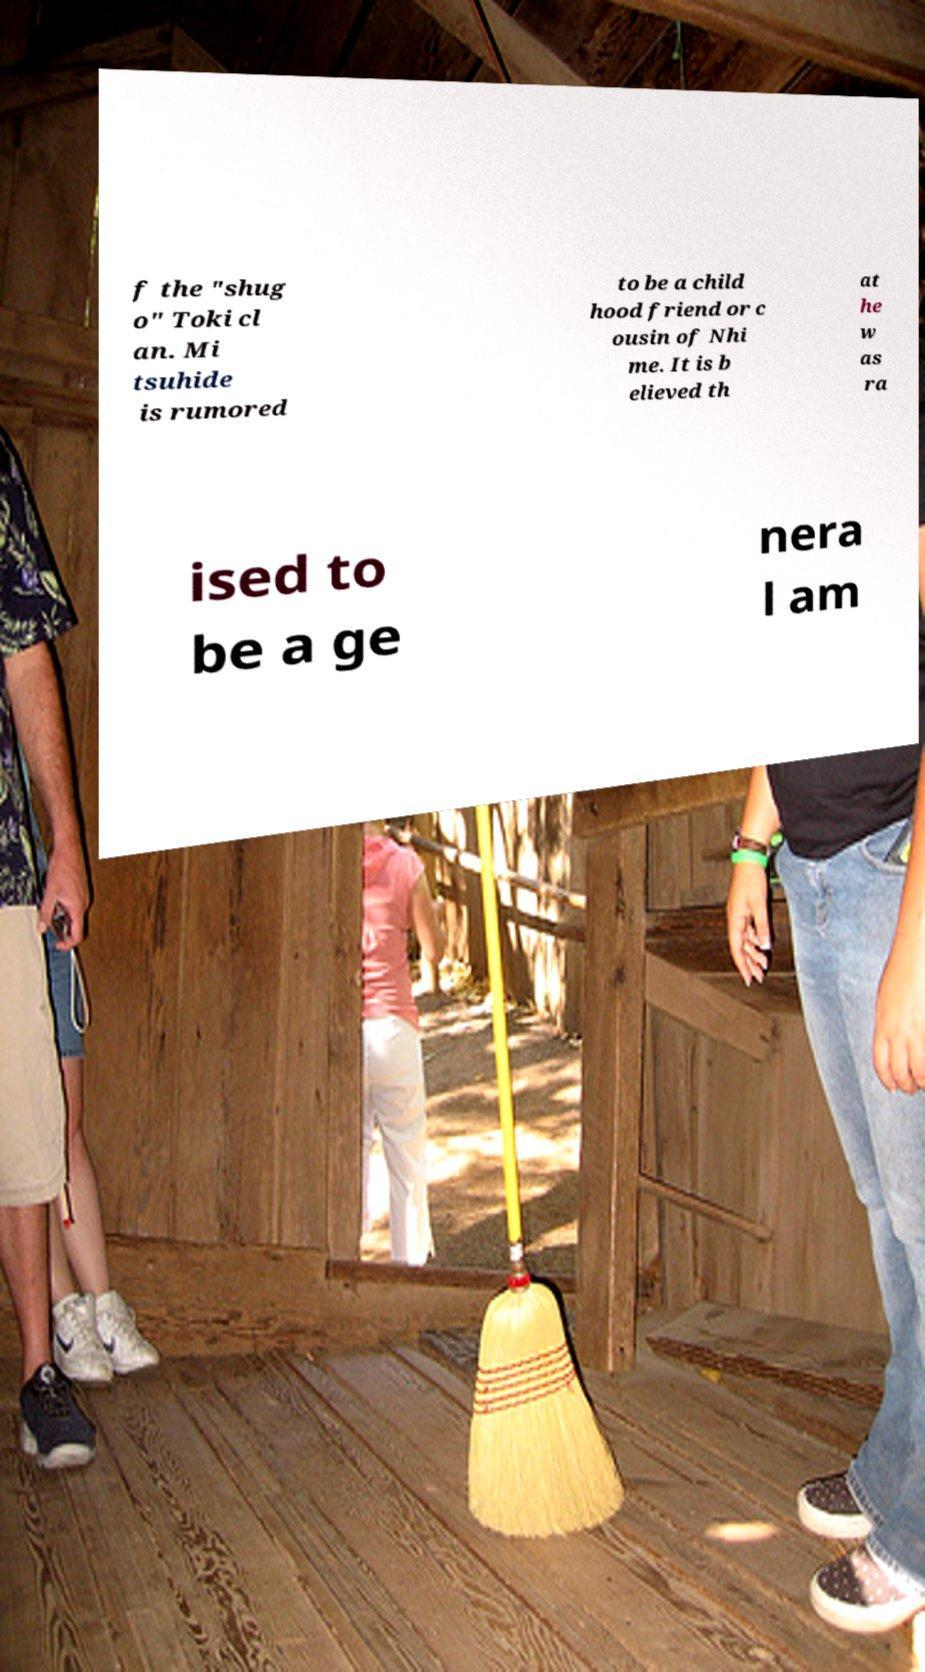Could you extract and type out the text from this image? f the "shug o" Toki cl an. Mi tsuhide is rumored to be a child hood friend or c ousin of Nhi me. It is b elieved th at he w as ra ised to be a ge nera l am 